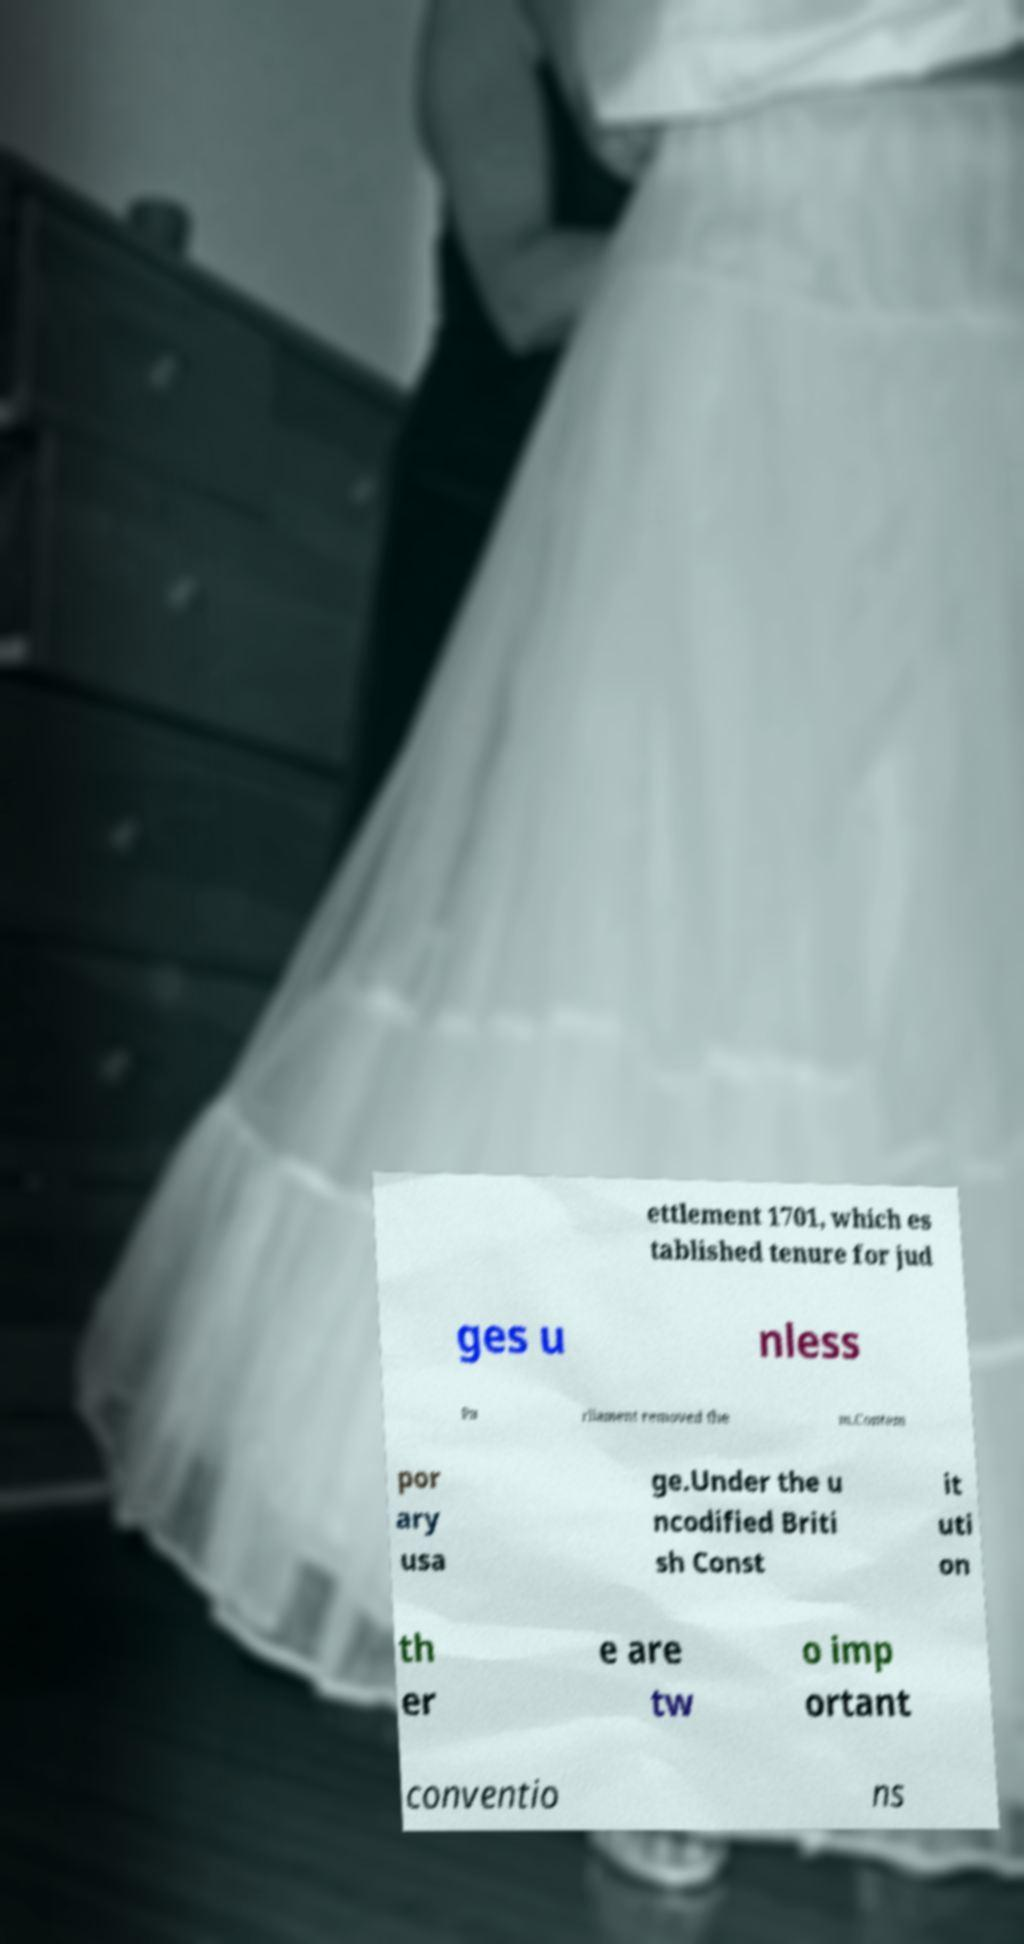There's text embedded in this image that I need extracted. Can you transcribe it verbatim? ettlement 1701, which es tablished tenure for jud ges u nless Pa rliament removed the m.Contem por ary usa ge.Under the u ncodified Briti sh Const it uti on th er e are tw o imp ortant conventio ns 